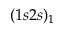Convert formula to latex. <formula><loc_0><loc_0><loc_500><loc_500>( 1 s 2 s ) _ { 1 }</formula> 